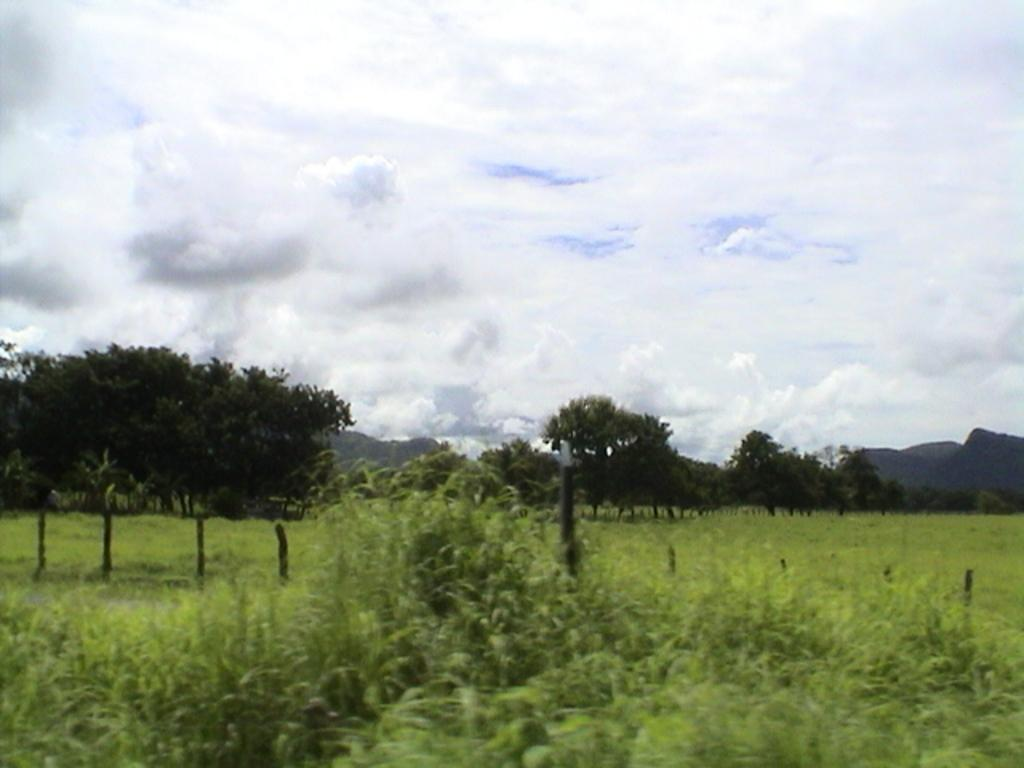What type of vegetation can be seen in the image? There are plants, grasslands, and trees in the image. What type of terrain is visible in the image? There are hills in the image. Is there any man-made structure present in the image? Yes, there is a fence in the image. What is the condition of the sky in the background of the image? The sky is cloudy in the background of the image. What hobbies are the plants engaging in during the day in the image? Plants do not engage in hobbies, as they are living organisms and not capable of such activities. 